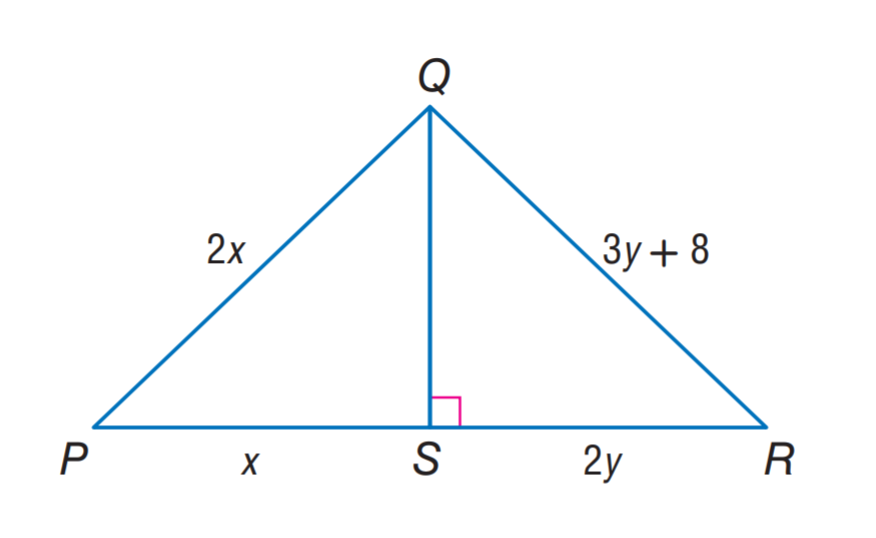Answer the mathemtical geometry problem and directly provide the correct option letter.
Question: \triangle P Q S \cong \triangle R Q S. Find x.
Choices: A: 8 B: 12 C: 16 D: 20 C 